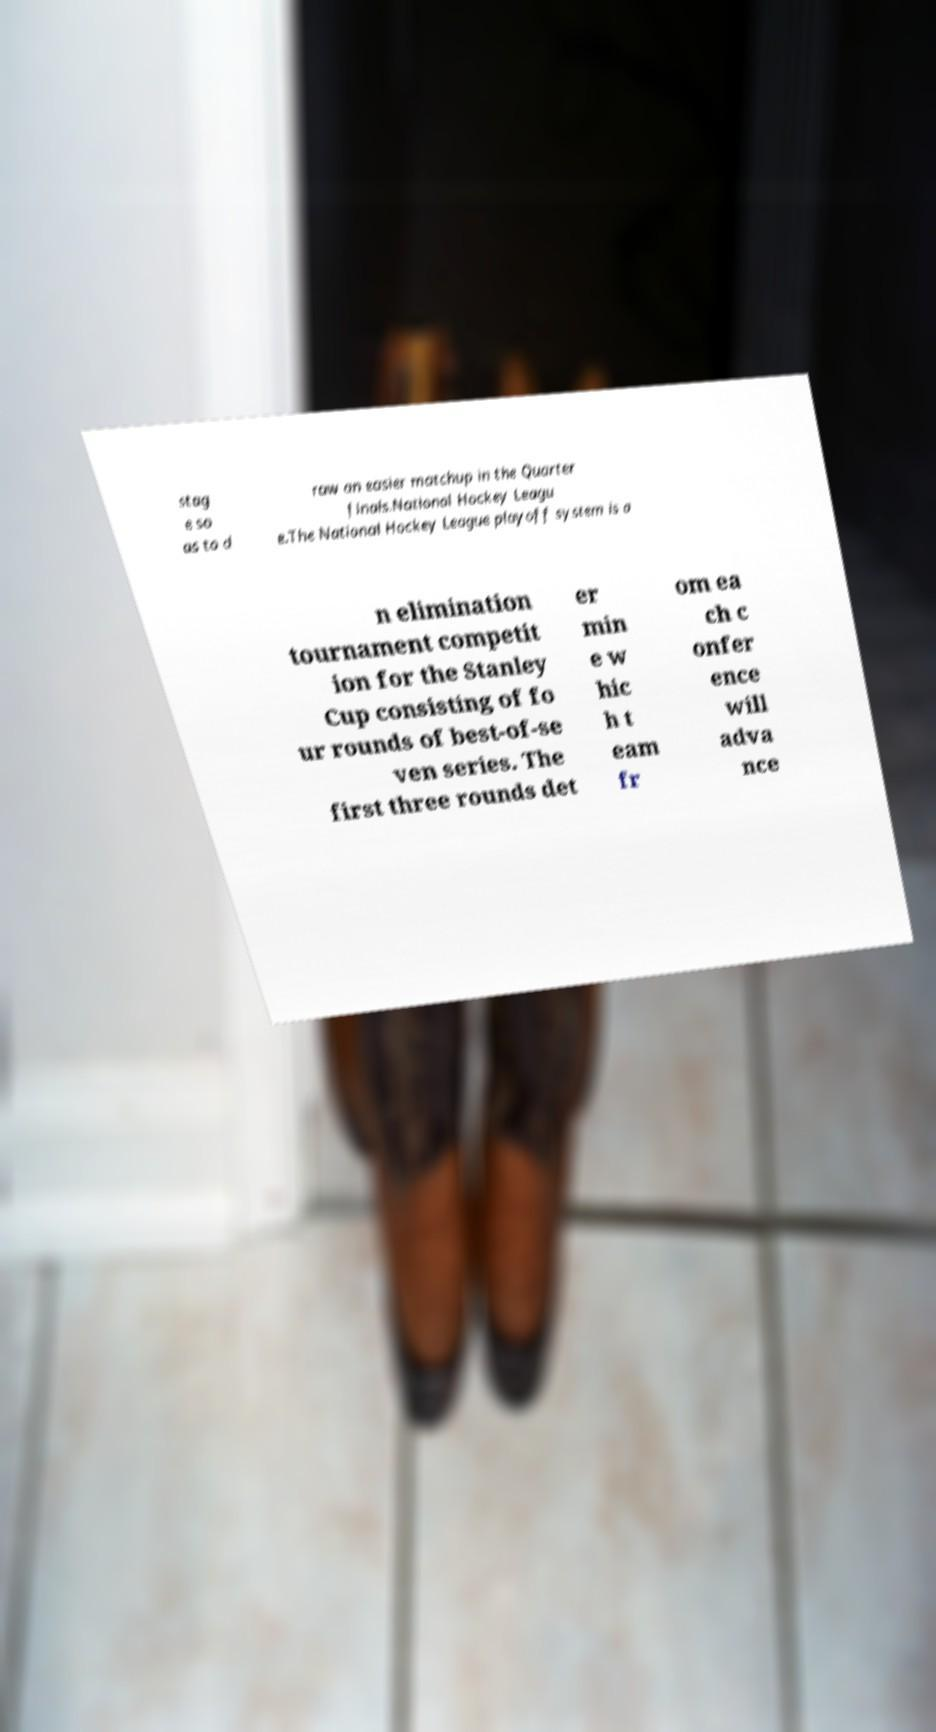I need the written content from this picture converted into text. Can you do that? stag e so as to d raw an easier matchup in the Quarter finals.National Hockey Leagu e.The National Hockey League playoff system is a n elimination tournament competit ion for the Stanley Cup consisting of fo ur rounds of best-of-se ven series. The first three rounds det er min e w hic h t eam fr om ea ch c onfer ence will adva nce 